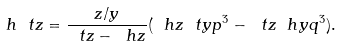Convert formula to latex. <formula><loc_0><loc_0><loc_500><loc_500>\ h { \ t z } = \frac { z / y } { \ t z - \ h z } ( \ h z \ t y p ^ { 3 } - \ t z \ h y q ^ { 3 } ) .</formula> 